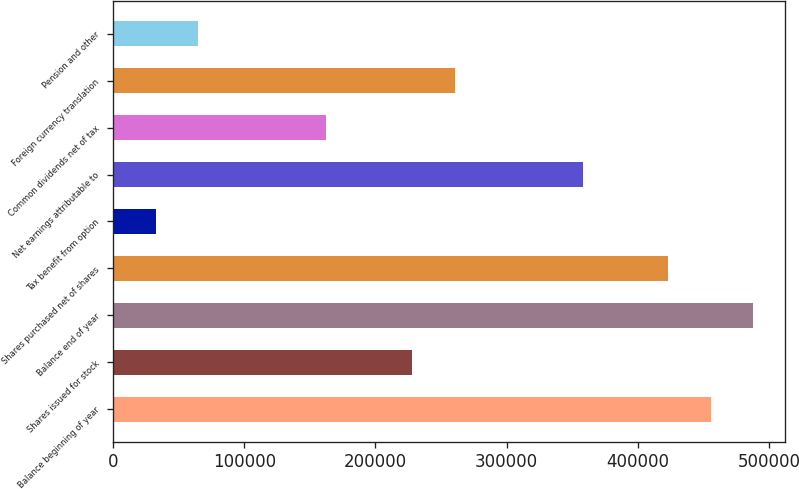<chart> <loc_0><loc_0><loc_500><loc_500><bar_chart><fcel>Balance beginning of year<fcel>Shares issued for stock<fcel>Balance end of year<fcel>Shares purchased net of shares<fcel>Tax benefit from option<fcel>Net earnings attributable to<fcel>Common dividends net of tax<fcel>Foreign currency translation<fcel>Pension and other<nl><fcel>455590<fcel>227798<fcel>488132<fcel>423048<fcel>32547.2<fcel>357965<fcel>162714<fcel>260340<fcel>65089<nl></chart> 